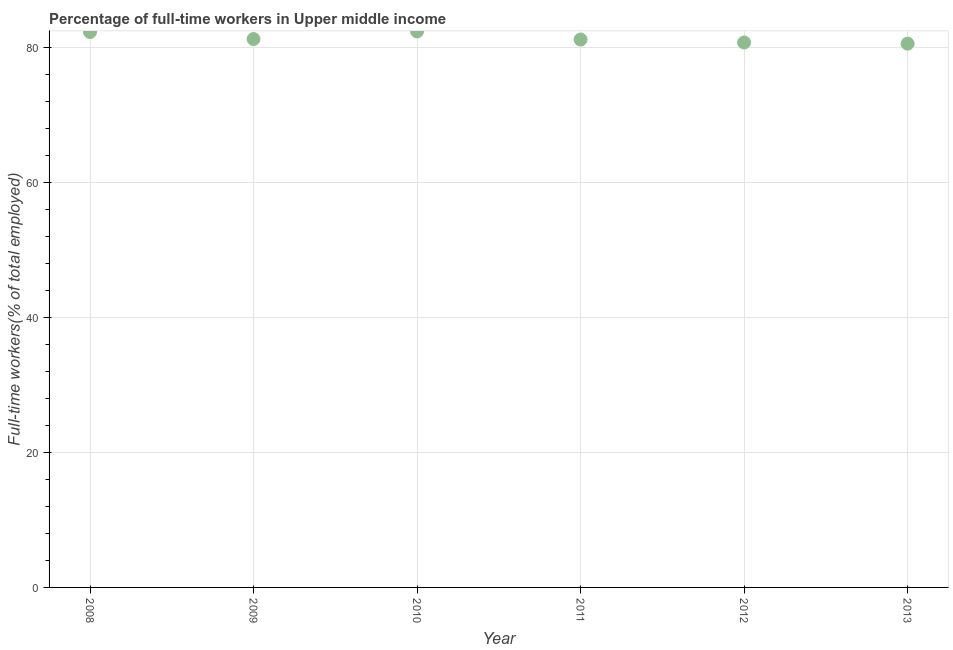What is the percentage of full-time workers in 2010?
Keep it short and to the point. 82.33. Across all years, what is the maximum percentage of full-time workers?
Your answer should be very brief. 82.33. Across all years, what is the minimum percentage of full-time workers?
Provide a short and direct response. 80.52. In which year was the percentage of full-time workers maximum?
Offer a terse response. 2010. What is the sum of the percentage of full-time workers?
Offer a very short reply. 488.12. What is the difference between the percentage of full-time workers in 2011 and 2012?
Your answer should be compact. 0.44. What is the average percentage of full-time workers per year?
Ensure brevity in your answer.  81.35. What is the median percentage of full-time workers?
Provide a short and direct response. 81.17. In how many years, is the percentage of full-time workers greater than 72 %?
Provide a succinct answer. 6. What is the ratio of the percentage of full-time workers in 2010 to that in 2013?
Keep it short and to the point. 1.02. Is the percentage of full-time workers in 2011 less than that in 2012?
Make the answer very short. No. What is the difference between the highest and the second highest percentage of full-time workers?
Provide a short and direct response. 0.08. What is the difference between the highest and the lowest percentage of full-time workers?
Your answer should be very brief. 1.81. What is the difference between two consecutive major ticks on the Y-axis?
Your response must be concise. 20. Does the graph contain any zero values?
Your answer should be compact. No. What is the title of the graph?
Your response must be concise. Percentage of full-time workers in Upper middle income. What is the label or title of the X-axis?
Provide a short and direct response. Year. What is the label or title of the Y-axis?
Your answer should be very brief. Full-time workers(% of total employed). What is the Full-time workers(% of total employed) in 2008?
Ensure brevity in your answer.  82.24. What is the Full-time workers(% of total employed) in 2009?
Your answer should be compact. 81.21. What is the Full-time workers(% of total employed) in 2010?
Make the answer very short. 82.33. What is the Full-time workers(% of total employed) in 2011?
Provide a succinct answer. 81.13. What is the Full-time workers(% of total employed) in 2012?
Provide a succinct answer. 80.69. What is the Full-time workers(% of total employed) in 2013?
Your answer should be very brief. 80.52. What is the difference between the Full-time workers(% of total employed) in 2008 and 2009?
Ensure brevity in your answer.  1.04. What is the difference between the Full-time workers(% of total employed) in 2008 and 2010?
Ensure brevity in your answer.  -0.08. What is the difference between the Full-time workers(% of total employed) in 2008 and 2011?
Your answer should be very brief. 1.11. What is the difference between the Full-time workers(% of total employed) in 2008 and 2012?
Offer a very short reply. 1.56. What is the difference between the Full-time workers(% of total employed) in 2008 and 2013?
Your response must be concise. 1.72. What is the difference between the Full-time workers(% of total employed) in 2009 and 2010?
Your answer should be compact. -1.12. What is the difference between the Full-time workers(% of total employed) in 2009 and 2011?
Your response must be concise. 0.07. What is the difference between the Full-time workers(% of total employed) in 2009 and 2012?
Give a very brief answer. 0.52. What is the difference between the Full-time workers(% of total employed) in 2009 and 2013?
Provide a succinct answer. 0.69. What is the difference between the Full-time workers(% of total employed) in 2010 and 2011?
Offer a very short reply. 1.2. What is the difference between the Full-time workers(% of total employed) in 2010 and 2012?
Your answer should be compact. 1.64. What is the difference between the Full-time workers(% of total employed) in 2010 and 2013?
Ensure brevity in your answer.  1.81. What is the difference between the Full-time workers(% of total employed) in 2011 and 2012?
Provide a short and direct response. 0.44. What is the difference between the Full-time workers(% of total employed) in 2011 and 2013?
Your response must be concise. 0.61. What is the difference between the Full-time workers(% of total employed) in 2012 and 2013?
Provide a succinct answer. 0.17. What is the ratio of the Full-time workers(% of total employed) in 2009 to that in 2010?
Provide a short and direct response. 0.99. What is the ratio of the Full-time workers(% of total employed) in 2009 to that in 2012?
Ensure brevity in your answer.  1.01. What is the ratio of the Full-time workers(% of total employed) in 2009 to that in 2013?
Provide a short and direct response. 1.01. What is the ratio of the Full-time workers(% of total employed) in 2010 to that in 2011?
Your answer should be compact. 1.01. What is the ratio of the Full-time workers(% of total employed) in 2010 to that in 2013?
Keep it short and to the point. 1.02. What is the ratio of the Full-time workers(% of total employed) in 2011 to that in 2013?
Make the answer very short. 1.01. 